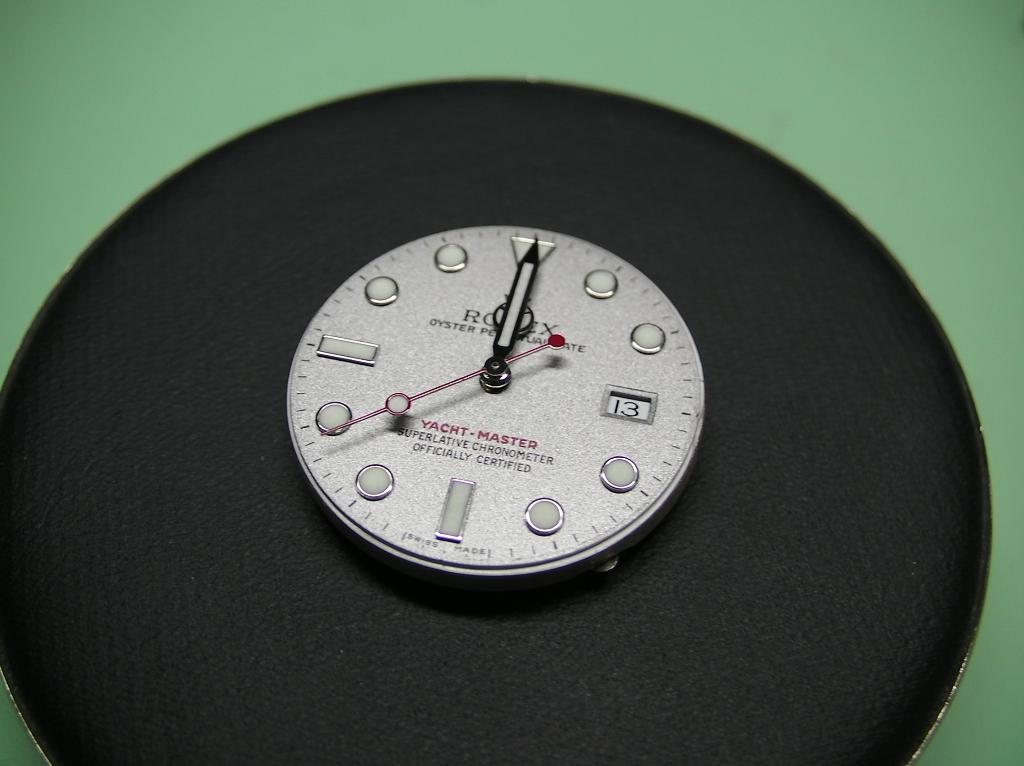Provide a one-sentence caption for the provided image. A round Yacht Master Superlative Chronometer sitting on a black surface. 